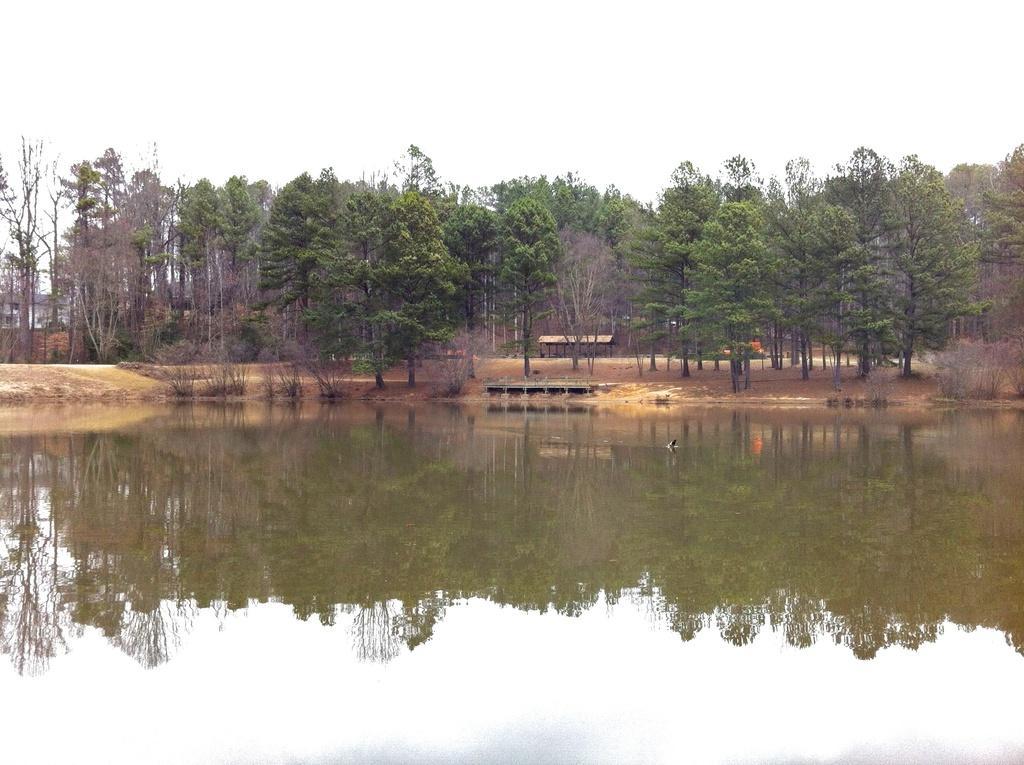Describe this image in one or two sentences. In this image we can see a large group of trees and plants. We can also see the water. On the backside we can see a house with roof and the sky which looks cloudy. 